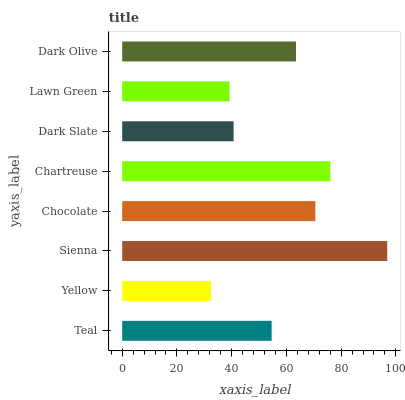Is Yellow the minimum?
Answer yes or no. Yes. Is Sienna the maximum?
Answer yes or no. Yes. Is Sienna the minimum?
Answer yes or no. No. Is Yellow the maximum?
Answer yes or no. No. Is Sienna greater than Yellow?
Answer yes or no. Yes. Is Yellow less than Sienna?
Answer yes or no. Yes. Is Yellow greater than Sienna?
Answer yes or no. No. Is Sienna less than Yellow?
Answer yes or no. No. Is Dark Olive the high median?
Answer yes or no. Yes. Is Teal the low median?
Answer yes or no. Yes. Is Yellow the high median?
Answer yes or no. No. Is Chocolate the low median?
Answer yes or no. No. 